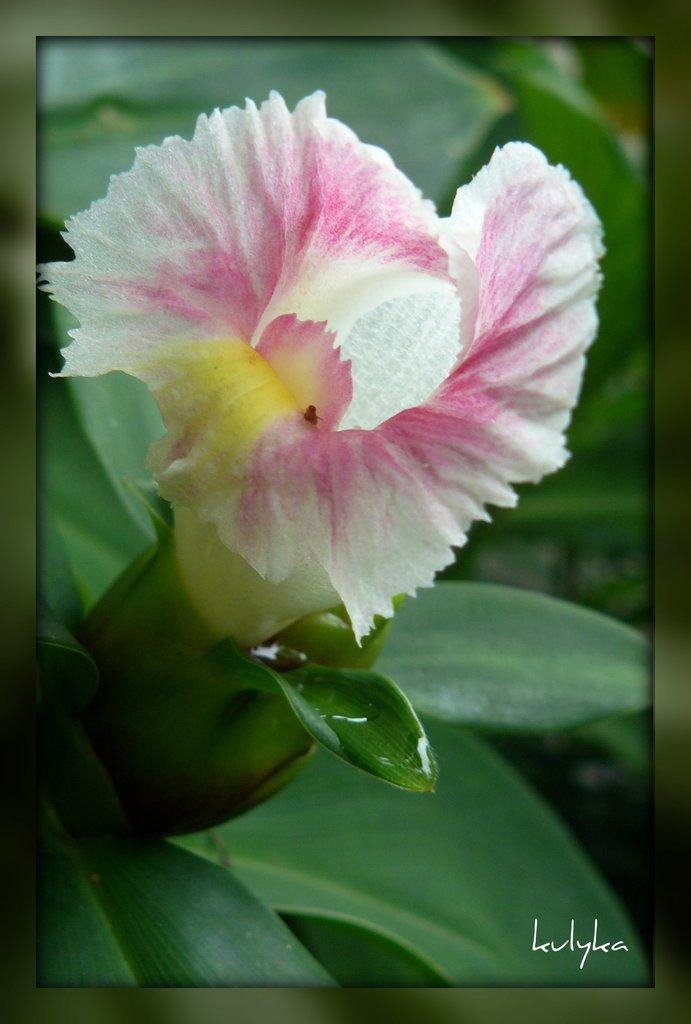What is the main subject of the image? There is a frame in the image. What is inside the frame? There is a flower and leaves in the frame. Is there any text present in the image? Yes, there is text written at the bottom of the image. How many oranges are visible in the image? There are no oranges present in the image. Are there any sheep in the frame? There are no sheep present in the image. 